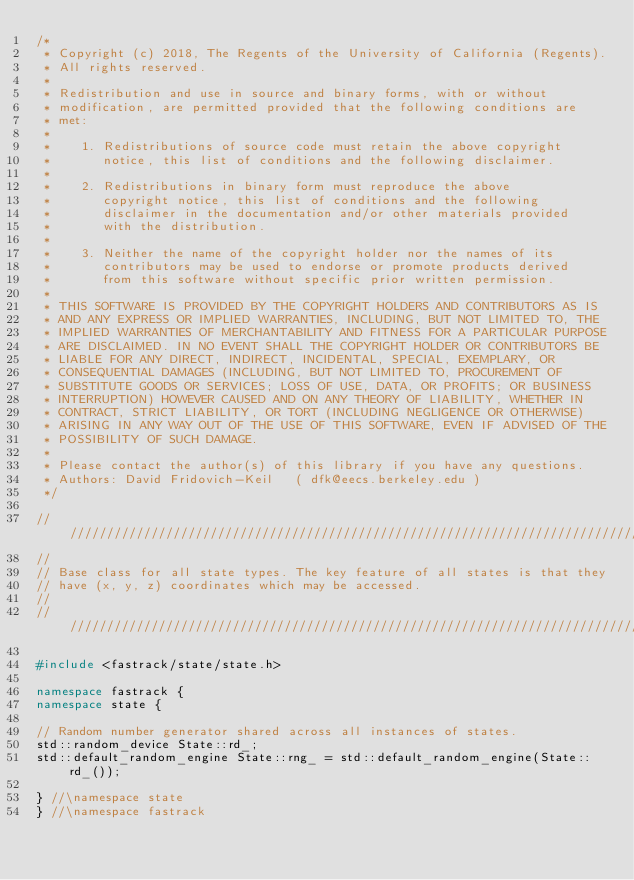<code> <loc_0><loc_0><loc_500><loc_500><_C++_>/*
 * Copyright (c) 2018, The Regents of the University of California (Regents).
 * All rights reserved.
 *
 * Redistribution and use in source and binary forms, with or without
 * modification, are permitted provided that the following conditions are
 * met:
 *
 *    1. Redistributions of source code must retain the above copyright
 *       notice, this list of conditions and the following disclaimer.
 *
 *    2. Redistributions in binary form must reproduce the above
 *       copyright notice, this list of conditions and the following
 *       disclaimer in the documentation and/or other materials provided
 *       with the distribution.
 *
 *    3. Neither the name of the copyright holder nor the names of its
 *       contributors may be used to endorse or promote products derived
 *       from this software without specific prior written permission.
 *
 * THIS SOFTWARE IS PROVIDED BY THE COPYRIGHT HOLDERS AND CONTRIBUTORS AS IS
 * AND ANY EXPRESS OR IMPLIED WARRANTIES, INCLUDING, BUT NOT LIMITED TO, THE
 * IMPLIED WARRANTIES OF MERCHANTABILITY AND FITNESS FOR A PARTICULAR PURPOSE
 * ARE DISCLAIMED. IN NO EVENT SHALL THE COPYRIGHT HOLDER OR CONTRIBUTORS BE
 * LIABLE FOR ANY DIRECT, INDIRECT, INCIDENTAL, SPECIAL, EXEMPLARY, OR
 * CONSEQUENTIAL DAMAGES (INCLUDING, BUT NOT LIMITED TO, PROCUREMENT OF
 * SUBSTITUTE GOODS OR SERVICES; LOSS OF USE, DATA, OR PROFITS; OR BUSINESS
 * INTERRUPTION) HOWEVER CAUSED AND ON ANY THEORY OF LIABILITY, WHETHER IN
 * CONTRACT, STRICT LIABILITY, OR TORT (INCLUDING NEGLIGENCE OR OTHERWISE)
 * ARISING IN ANY WAY OUT OF THE USE OF THIS SOFTWARE, EVEN IF ADVISED OF THE
 * POSSIBILITY OF SUCH DAMAGE.
 *
 * Please contact the author(s) of this library if you have any questions.
 * Authors: David Fridovich-Keil   ( dfk@eecs.berkeley.edu )
 */

///////////////////////////////////////////////////////////////////////////////
//
// Base class for all state types. The key feature of all states is that they
// have (x, y, z) coordinates which may be accessed.
//
///////////////////////////////////////////////////////////////////////////////

#include <fastrack/state/state.h>

namespace fastrack {
namespace state {

// Random number generator shared across all instances of states.
std::random_device State::rd_;
std::default_random_engine State::rng_ = std::default_random_engine(State::rd_());

} //\namespace state
} //\namespace fastrack
</code> 